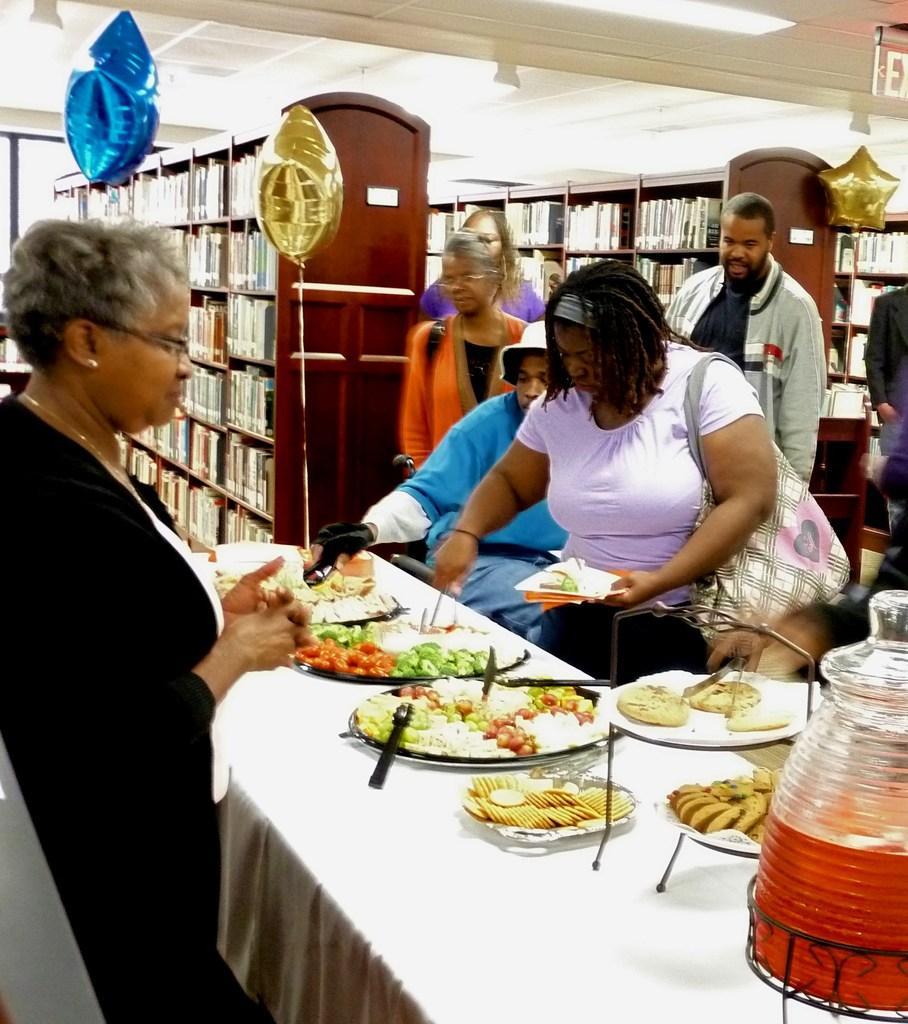Please provide a concise description of this image. In this image we can see some food items and a jar with a drink in it are kept on the table with white color table cloth. Here we can see these people are standing on the floor, we can see balloons, books kept in wooden cupboards, ceiling lights and exit board. 